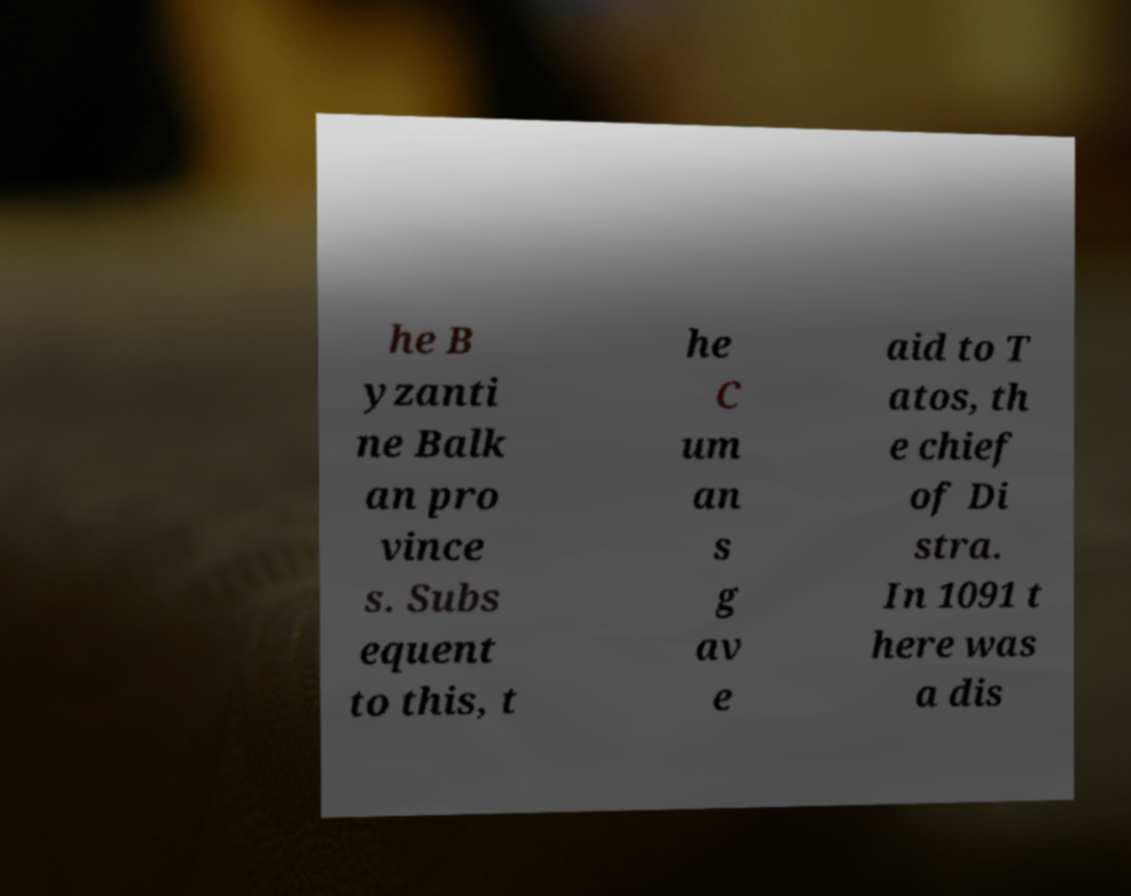Could you assist in decoding the text presented in this image and type it out clearly? he B yzanti ne Balk an pro vince s. Subs equent to this, t he C um an s g av e aid to T atos, th e chief of Di stra. In 1091 t here was a dis 